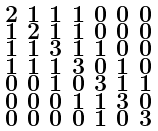<formula> <loc_0><loc_0><loc_500><loc_500>\begin{smallmatrix} 2 & 1 & 1 & 1 & 0 & 0 & 0 \\ 1 & 2 & 1 & 1 & 0 & 0 & 0 \\ 1 & 1 & 3 & 1 & 1 & 0 & 0 \\ 1 & 1 & 1 & 3 & 0 & 1 & 0 \\ 0 & 0 & 1 & 0 & 3 & 1 & 1 \\ 0 & 0 & 0 & 1 & 1 & 3 & 0 \\ 0 & 0 & 0 & 0 & 1 & 0 & 3 \end{smallmatrix}</formula> 